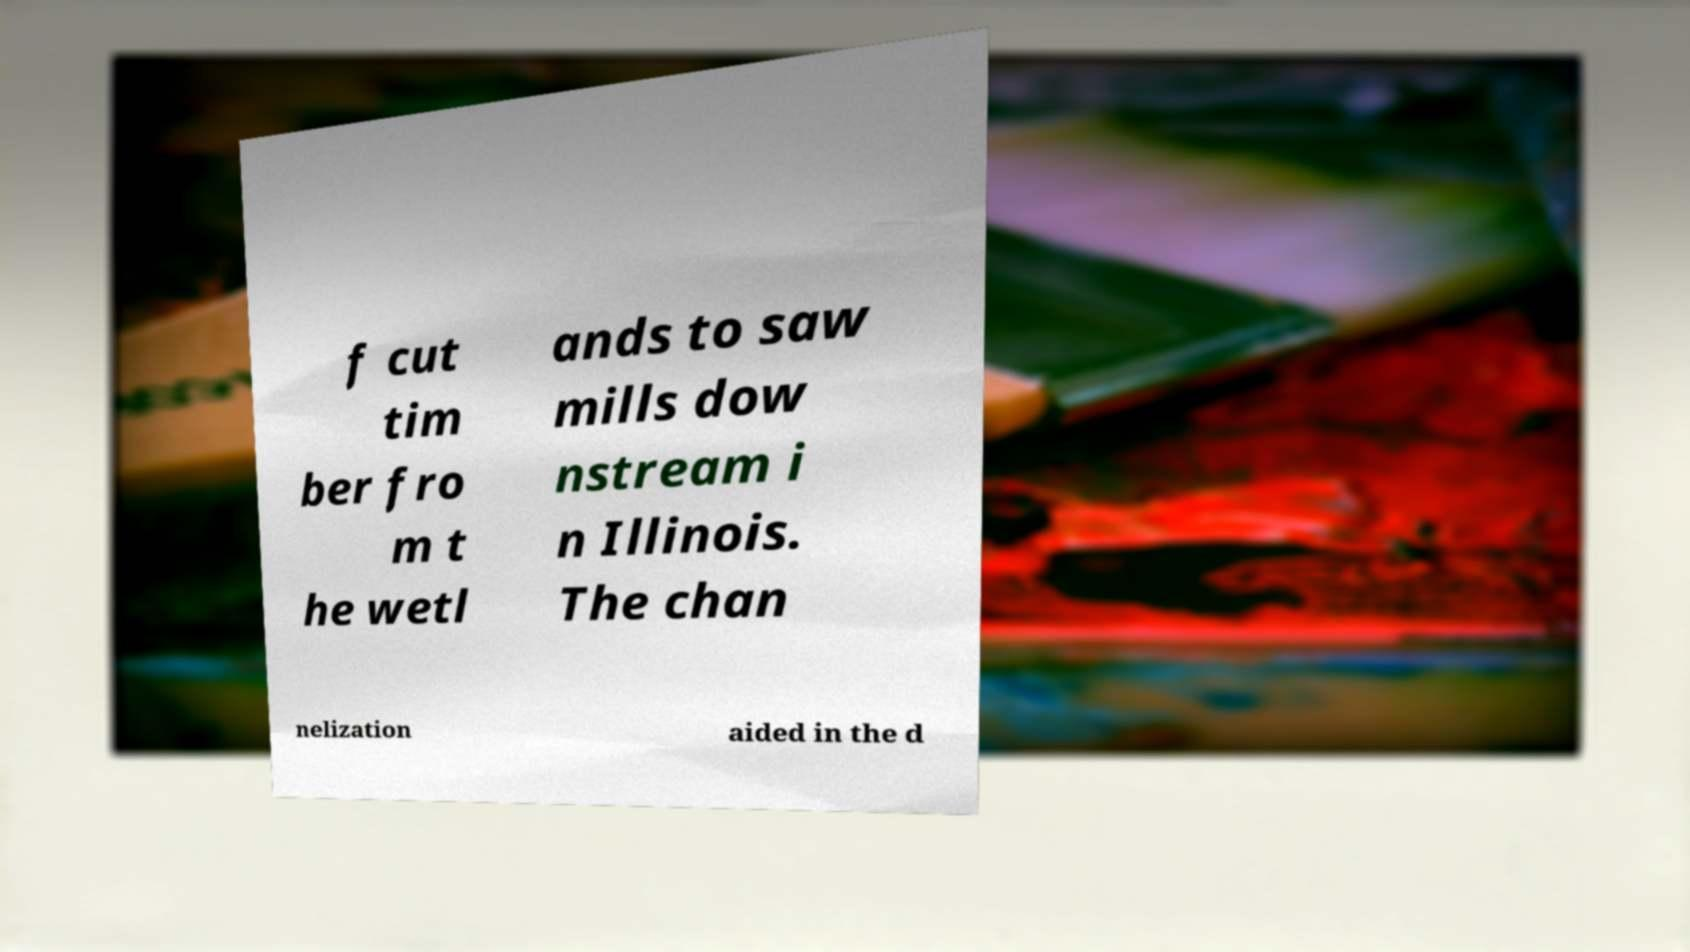Could you assist in decoding the text presented in this image and type it out clearly? f cut tim ber fro m t he wetl ands to saw mills dow nstream i n Illinois. The chan nelization aided in the d 